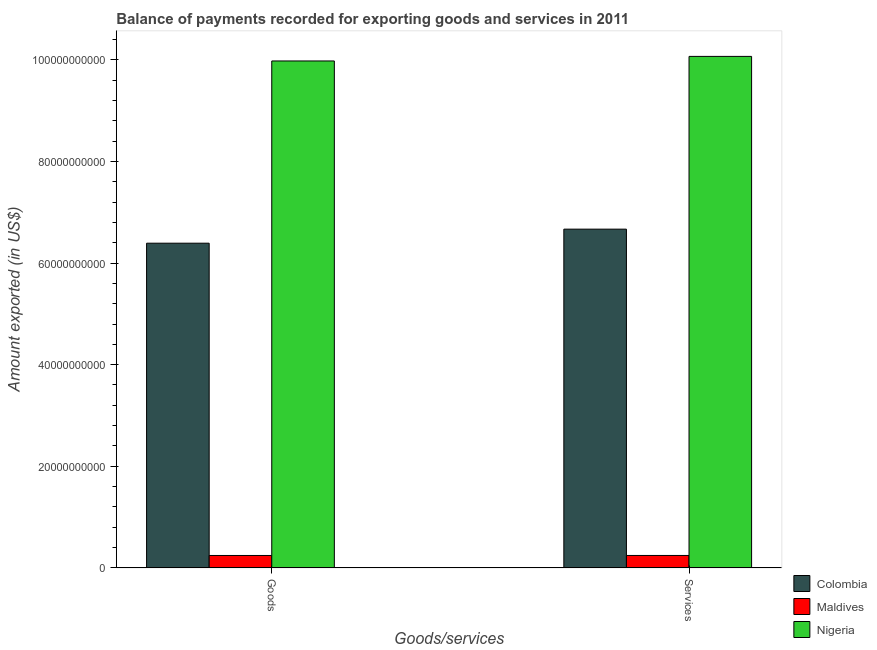How many groups of bars are there?
Your answer should be compact. 2. How many bars are there on the 2nd tick from the left?
Your answer should be very brief. 3. What is the label of the 2nd group of bars from the left?
Your answer should be very brief. Services. What is the amount of services exported in Maldives?
Your answer should be very brief. 2.46e+09. Across all countries, what is the maximum amount of goods exported?
Keep it short and to the point. 9.98e+1. Across all countries, what is the minimum amount of services exported?
Offer a very short reply. 2.46e+09. In which country was the amount of goods exported maximum?
Keep it short and to the point. Nigeria. In which country was the amount of services exported minimum?
Your answer should be compact. Maldives. What is the total amount of services exported in the graph?
Provide a succinct answer. 1.70e+11. What is the difference between the amount of services exported in Nigeria and that in Colombia?
Your response must be concise. 3.40e+1. What is the difference between the amount of services exported in Colombia and the amount of goods exported in Maldives?
Your answer should be compact. 6.42e+1. What is the average amount of services exported per country?
Provide a succinct answer. 5.66e+1. What is the difference between the amount of services exported and amount of goods exported in Colombia?
Give a very brief answer. 2.77e+09. In how many countries, is the amount of goods exported greater than 80000000000 US$?
Keep it short and to the point. 1. What is the ratio of the amount of services exported in Maldives to that in Colombia?
Make the answer very short. 0.04. Is the amount of goods exported in Colombia less than that in Nigeria?
Ensure brevity in your answer.  Yes. What does the 3rd bar from the left in Services represents?
Ensure brevity in your answer.  Nigeria. What does the 2nd bar from the right in Goods represents?
Offer a very short reply. Maldives. How many bars are there?
Provide a succinct answer. 6. What is the difference between two consecutive major ticks on the Y-axis?
Offer a very short reply. 2.00e+1. Does the graph contain any zero values?
Your answer should be very brief. No. What is the title of the graph?
Give a very brief answer. Balance of payments recorded for exporting goods and services in 2011. What is the label or title of the X-axis?
Offer a very short reply. Goods/services. What is the label or title of the Y-axis?
Your response must be concise. Amount exported (in US$). What is the Amount exported (in US$) in Colombia in Goods?
Your response must be concise. 6.39e+1. What is the Amount exported (in US$) in Maldives in Goods?
Your answer should be compact. 2.45e+09. What is the Amount exported (in US$) of Nigeria in Goods?
Your response must be concise. 9.98e+1. What is the Amount exported (in US$) of Colombia in Services?
Your answer should be very brief. 6.67e+1. What is the Amount exported (in US$) of Maldives in Services?
Your answer should be very brief. 2.46e+09. What is the Amount exported (in US$) of Nigeria in Services?
Give a very brief answer. 1.01e+11. Across all Goods/services, what is the maximum Amount exported (in US$) in Colombia?
Provide a succinct answer. 6.67e+1. Across all Goods/services, what is the maximum Amount exported (in US$) of Maldives?
Your answer should be very brief. 2.46e+09. Across all Goods/services, what is the maximum Amount exported (in US$) of Nigeria?
Give a very brief answer. 1.01e+11. Across all Goods/services, what is the minimum Amount exported (in US$) in Colombia?
Offer a terse response. 6.39e+1. Across all Goods/services, what is the minimum Amount exported (in US$) in Maldives?
Provide a short and direct response. 2.45e+09. Across all Goods/services, what is the minimum Amount exported (in US$) in Nigeria?
Provide a succinct answer. 9.98e+1. What is the total Amount exported (in US$) of Colombia in the graph?
Give a very brief answer. 1.31e+11. What is the total Amount exported (in US$) of Maldives in the graph?
Your answer should be very brief. 4.91e+09. What is the total Amount exported (in US$) of Nigeria in the graph?
Keep it short and to the point. 2.00e+11. What is the difference between the Amount exported (in US$) of Colombia in Goods and that in Services?
Provide a short and direct response. -2.77e+09. What is the difference between the Amount exported (in US$) in Maldives in Goods and that in Services?
Your response must be concise. -4.06e+06. What is the difference between the Amount exported (in US$) of Nigeria in Goods and that in Services?
Your answer should be compact. -8.98e+08. What is the difference between the Amount exported (in US$) of Colombia in Goods and the Amount exported (in US$) of Maldives in Services?
Your answer should be compact. 6.14e+1. What is the difference between the Amount exported (in US$) of Colombia in Goods and the Amount exported (in US$) of Nigeria in Services?
Offer a terse response. -3.68e+1. What is the difference between the Amount exported (in US$) in Maldives in Goods and the Amount exported (in US$) in Nigeria in Services?
Offer a terse response. -9.82e+1. What is the average Amount exported (in US$) of Colombia per Goods/services?
Give a very brief answer. 6.53e+1. What is the average Amount exported (in US$) of Maldives per Goods/services?
Your answer should be compact. 2.46e+09. What is the average Amount exported (in US$) of Nigeria per Goods/services?
Your answer should be compact. 1.00e+11. What is the difference between the Amount exported (in US$) of Colombia and Amount exported (in US$) of Maldives in Goods?
Make the answer very short. 6.14e+1. What is the difference between the Amount exported (in US$) in Colombia and Amount exported (in US$) in Nigeria in Goods?
Make the answer very short. -3.59e+1. What is the difference between the Amount exported (in US$) in Maldives and Amount exported (in US$) in Nigeria in Goods?
Your answer should be very brief. -9.73e+1. What is the difference between the Amount exported (in US$) in Colombia and Amount exported (in US$) in Maldives in Services?
Offer a very short reply. 6.42e+1. What is the difference between the Amount exported (in US$) of Colombia and Amount exported (in US$) of Nigeria in Services?
Provide a succinct answer. -3.40e+1. What is the difference between the Amount exported (in US$) in Maldives and Amount exported (in US$) in Nigeria in Services?
Provide a succinct answer. -9.82e+1. What is the ratio of the Amount exported (in US$) in Colombia in Goods to that in Services?
Provide a short and direct response. 0.96. What is the ratio of the Amount exported (in US$) in Maldives in Goods to that in Services?
Your answer should be compact. 1. What is the ratio of the Amount exported (in US$) of Nigeria in Goods to that in Services?
Offer a very short reply. 0.99. What is the difference between the highest and the second highest Amount exported (in US$) of Colombia?
Offer a very short reply. 2.77e+09. What is the difference between the highest and the second highest Amount exported (in US$) of Maldives?
Offer a very short reply. 4.06e+06. What is the difference between the highest and the second highest Amount exported (in US$) in Nigeria?
Provide a succinct answer. 8.98e+08. What is the difference between the highest and the lowest Amount exported (in US$) of Colombia?
Keep it short and to the point. 2.77e+09. What is the difference between the highest and the lowest Amount exported (in US$) in Maldives?
Give a very brief answer. 4.06e+06. What is the difference between the highest and the lowest Amount exported (in US$) in Nigeria?
Your answer should be very brief. 8.98e+08. 